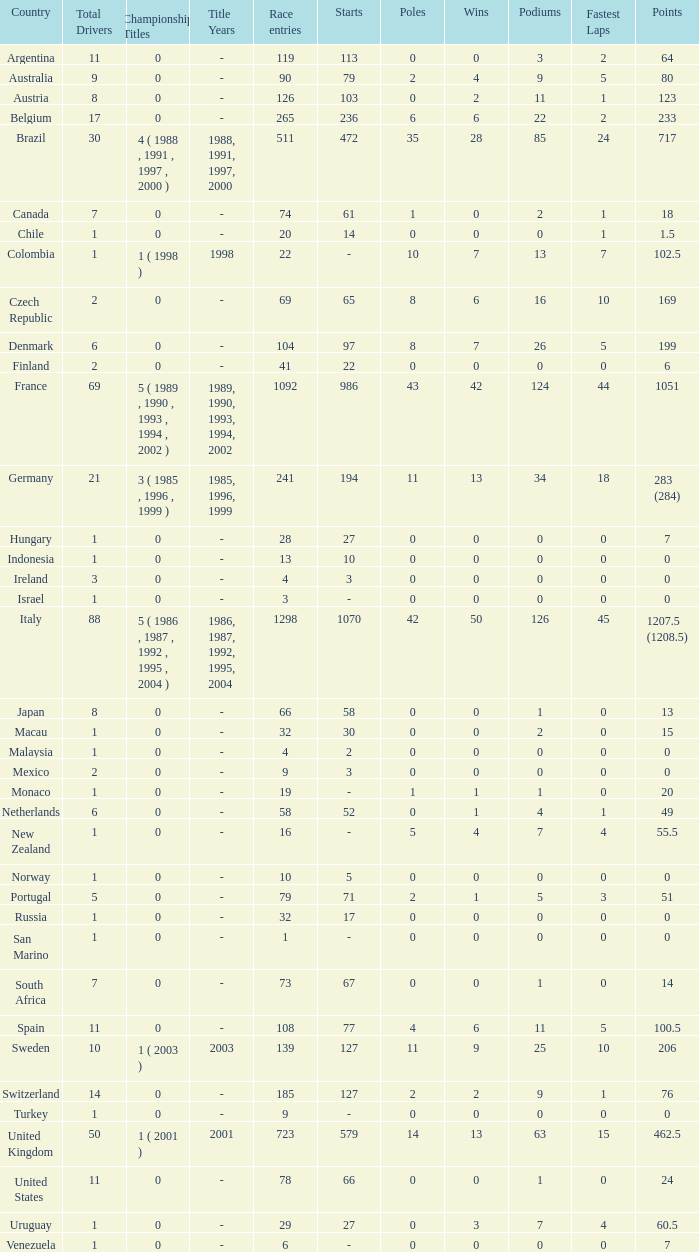How many titles for the nation with less than 3 fastest laps and 22 podiums? 0.0. 